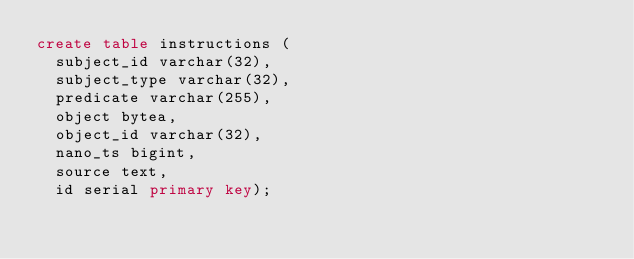Convert code to text. <code><loc_0><loc_0><loc_500><loc_500><_SQL_>create table instructions (
	subject_id varchar(32),
	subject_type varchar(32),
	predicate varchar(255),
	object bytea,
	object_id varchar(32),
	nano_ts bigint,
	source text,
	id serial primary key);
</code> 